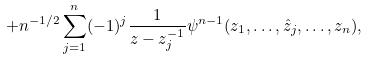Convert formula to latex. <formula><loc_0><loc_0><loc_500><loc_500>+ n ^ { - 1 / 2 } \sum _ { j = 1 } ^ { n } ( - 1 ) ^ { j } \frac { 1 } { z - z _ { j } ^ { - 1 } } \psi ^ { n - 1 } ( z _ { 1 } , \dots , \hat { z } _ { j } , \dots , z _ { n } ) ,</formula> 